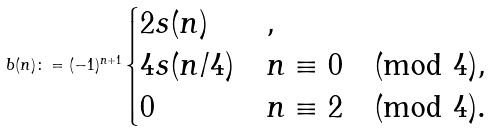Convert formula to latex. <formula><loc_0><loc_0><loc_500><loc_500>b ( n ) \colon = ( - 1 ) ^ { n + 1 } \begin{cases} 2 s ( n ) & , \\ 4 s ( n / 4 ) & n \equiv 0 \pmod { 4 } , \\ 0 & n \equiv 2 \pmod { 4 } . \end{cases}</formula> 